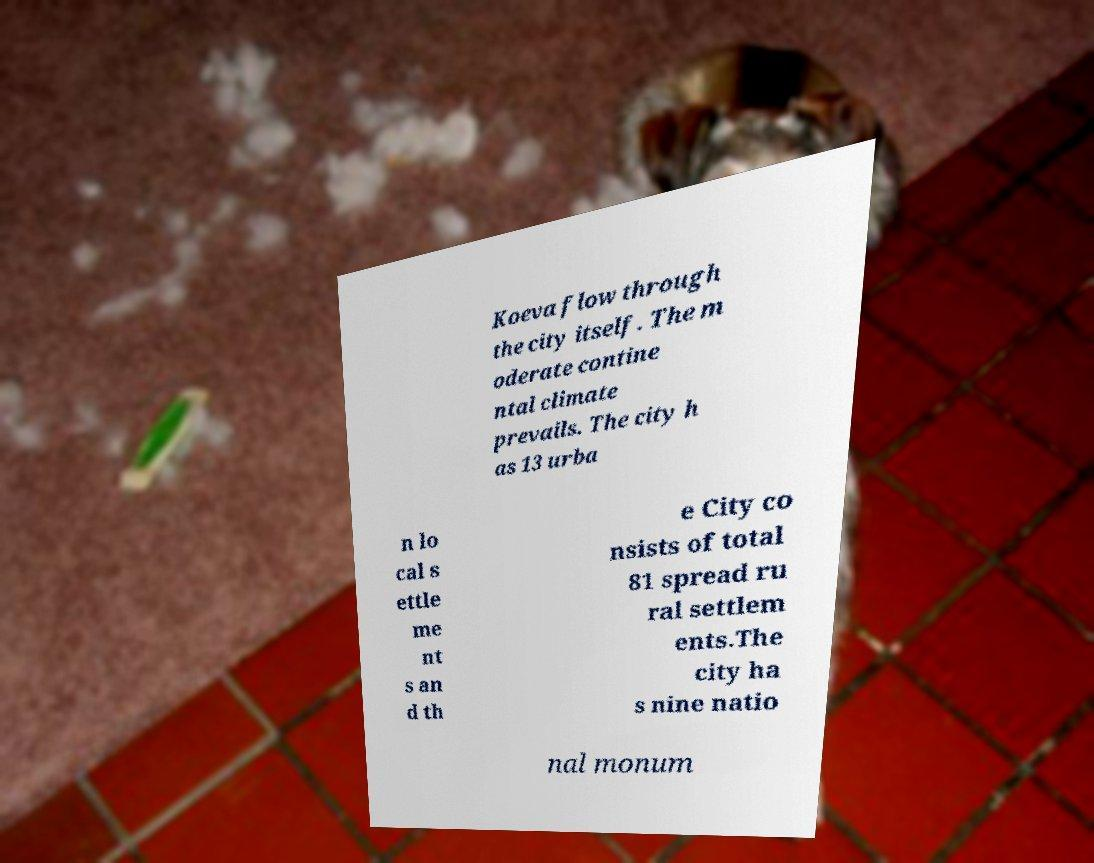There's text embedded in this image that I need extracted. Can you transcribe it verbatim? Koeva flow through the city itself. The m oderate contine ntal climate prevails. The city h as 13 urba n lo cal s ettle me nt s an d th e City co nsists of total 81 spread ru ral settlem ents.The city ha s nine natio nal monum 